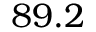<formula> <loc_0><loc_0><loc_500><loc_500>8 9 . 2</formula> 